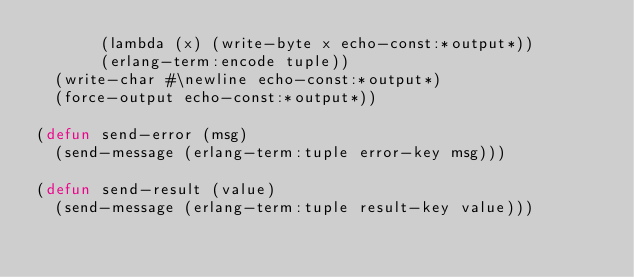Convert code to text. <code><loc_0><loc_0><loc_500><loc_500><_Lisp_>       (lambda (x) (write-byte x echo-const:*output*))
       (erlang-term:encode tuple))
  (write-char #\newline echo-const:*output*)
  (force-output echo-const:*output*))

(defun send-error (msg)
  (send-message (erlang-term:tuple error-key msg)))

(defun send-result (value)
  (send-message (erlang-term:tuple result-key value)))
</code> 